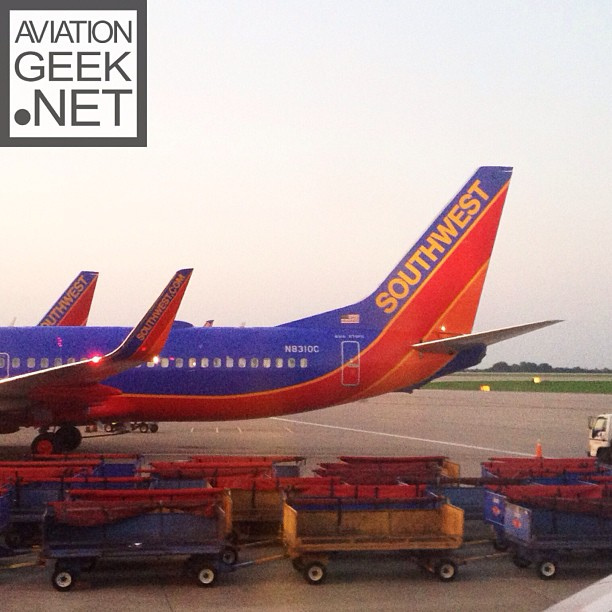Please transcribe the text in this image. AVIATION GEEK NET SOUTHWEST SOUTHWEST.COM N8310C 